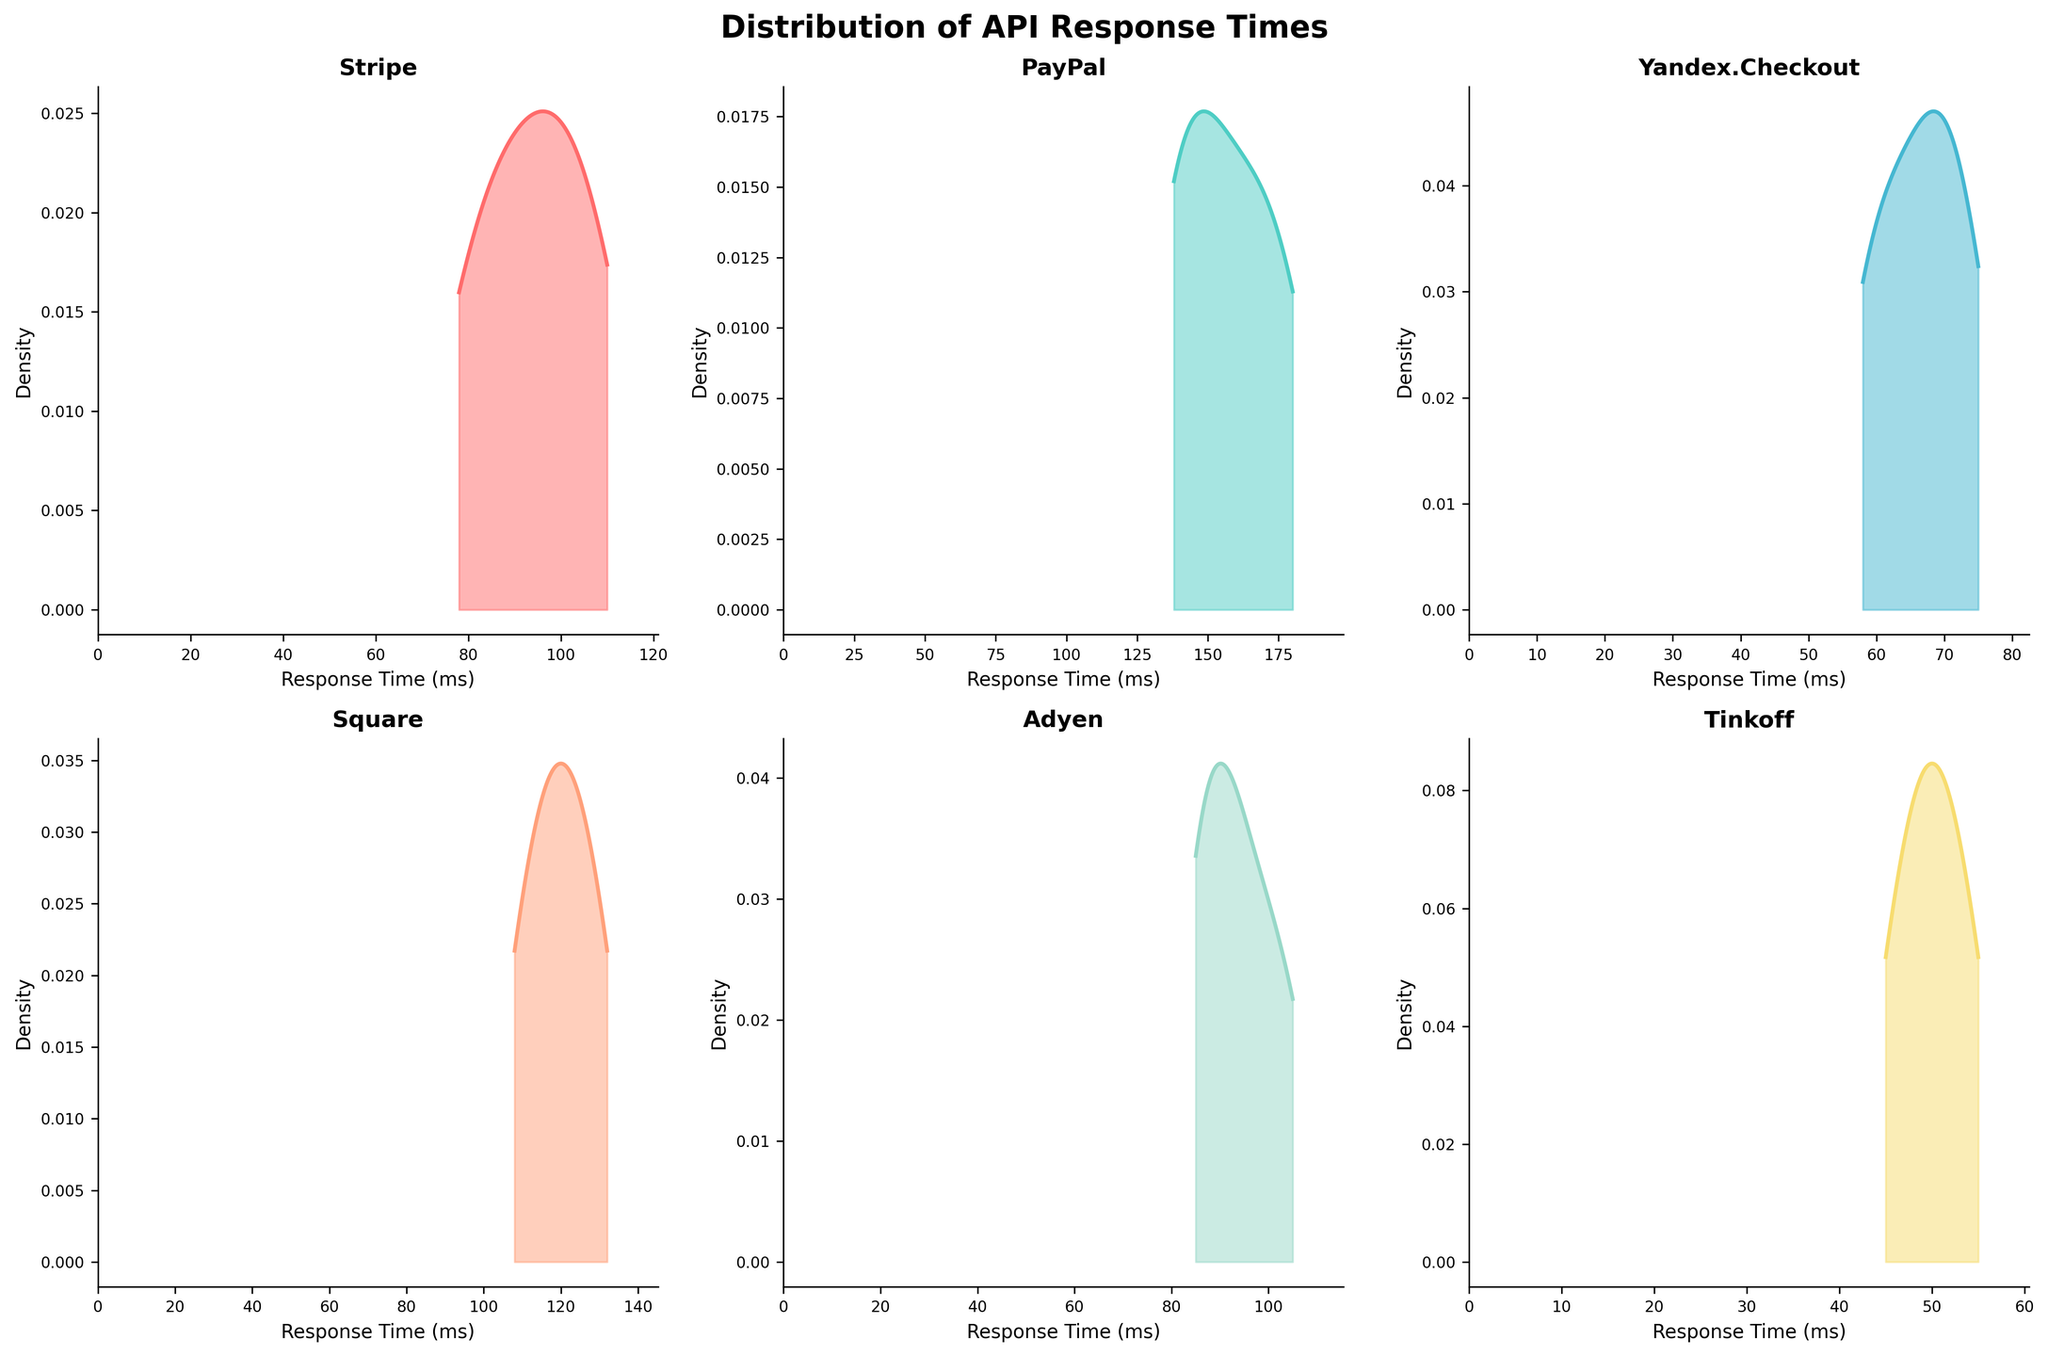How many libraries are presented in the figure? The density plots are generated for unique values of the 'library' column. Counting the unique titles in the subplots gives us the number of libraries.
Answer: 6 Which library has the widest range of response times? By visually comparing the range of the x-axes across subplots, PayPal shows the widest spread, indicating it has the widest range of response times.
Answer: PayPal Which library has the smallest range of response times? Identifying the smallest x-axis range among the subplots shows that Tinkoff has the smallest spread of response times.
Answer: Tinkoff Which library's density plot peaks the highest? The height of the peak represents the library with the highest density at a particular response time. Comparing all plots, Yandex.Checkout's peak is the highest.
Answer: Yandex.Checkout In which library does the mode fall below 50 ms? The mode is where the density curve peaks. Observing the plots, the peak for Tinkoff is below 50 ms.
Answer: Tinkoff What is the approximate mode response time for Stripe? The mode can be approximated by finding the highest point in Stripe’s density plot. The peak occurs around 90-100 ms.
Answer: 95 ms Which libraries have bimodal distributions? Bimodal distributions show two significant peaks. Comparing plots, Stripe shows two peaks around 80 ms and 100 ms, and PayPal shows peaks around 140 ms and 160 ms.
Answer: Stripe, PayPal How does the response time distribution of Adyen compare to Stripe? By comparing the shapes of the density plots, Adyen's plot is centered slightly lower (around 90 ms) than Stripe's, with less spread. Stripe is more spread out with a peak around 95 ms.
Answer: Adyen has a lower center and less spread Which library's distribution seems most symmetric? Symmetric distributions roughly mirror on either side of the peak. Adyen’s distribution looks the most symmetric around its peak.
Answer: Adyen Which library's response times are most concentrated around its mean? High concentration around the mean implies a narrow distribution. Yandex.Checkout's plot demonstrates this with a high peak and narrow spread.
Answer: Yandex.Checkout 